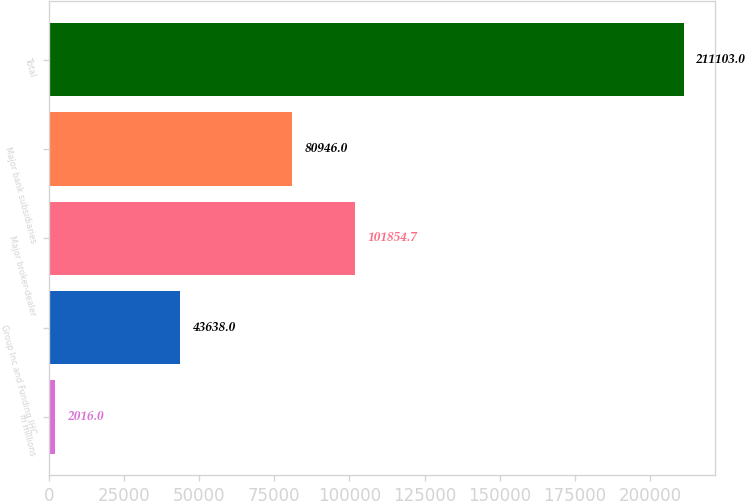Convert chart. <chart><loc_0><loc_0><loc_500><loc_500><bar_chart><fcel>in millions<fcel>Group Inc and Funding IHC<fcel>Major broker-dealer<fcel>Major bank subsidiaries<fcel>Total<nl><fcel>2016<fcel>43638<fcel>101855<fcel>80946<fcel>211103<nl></chart> 